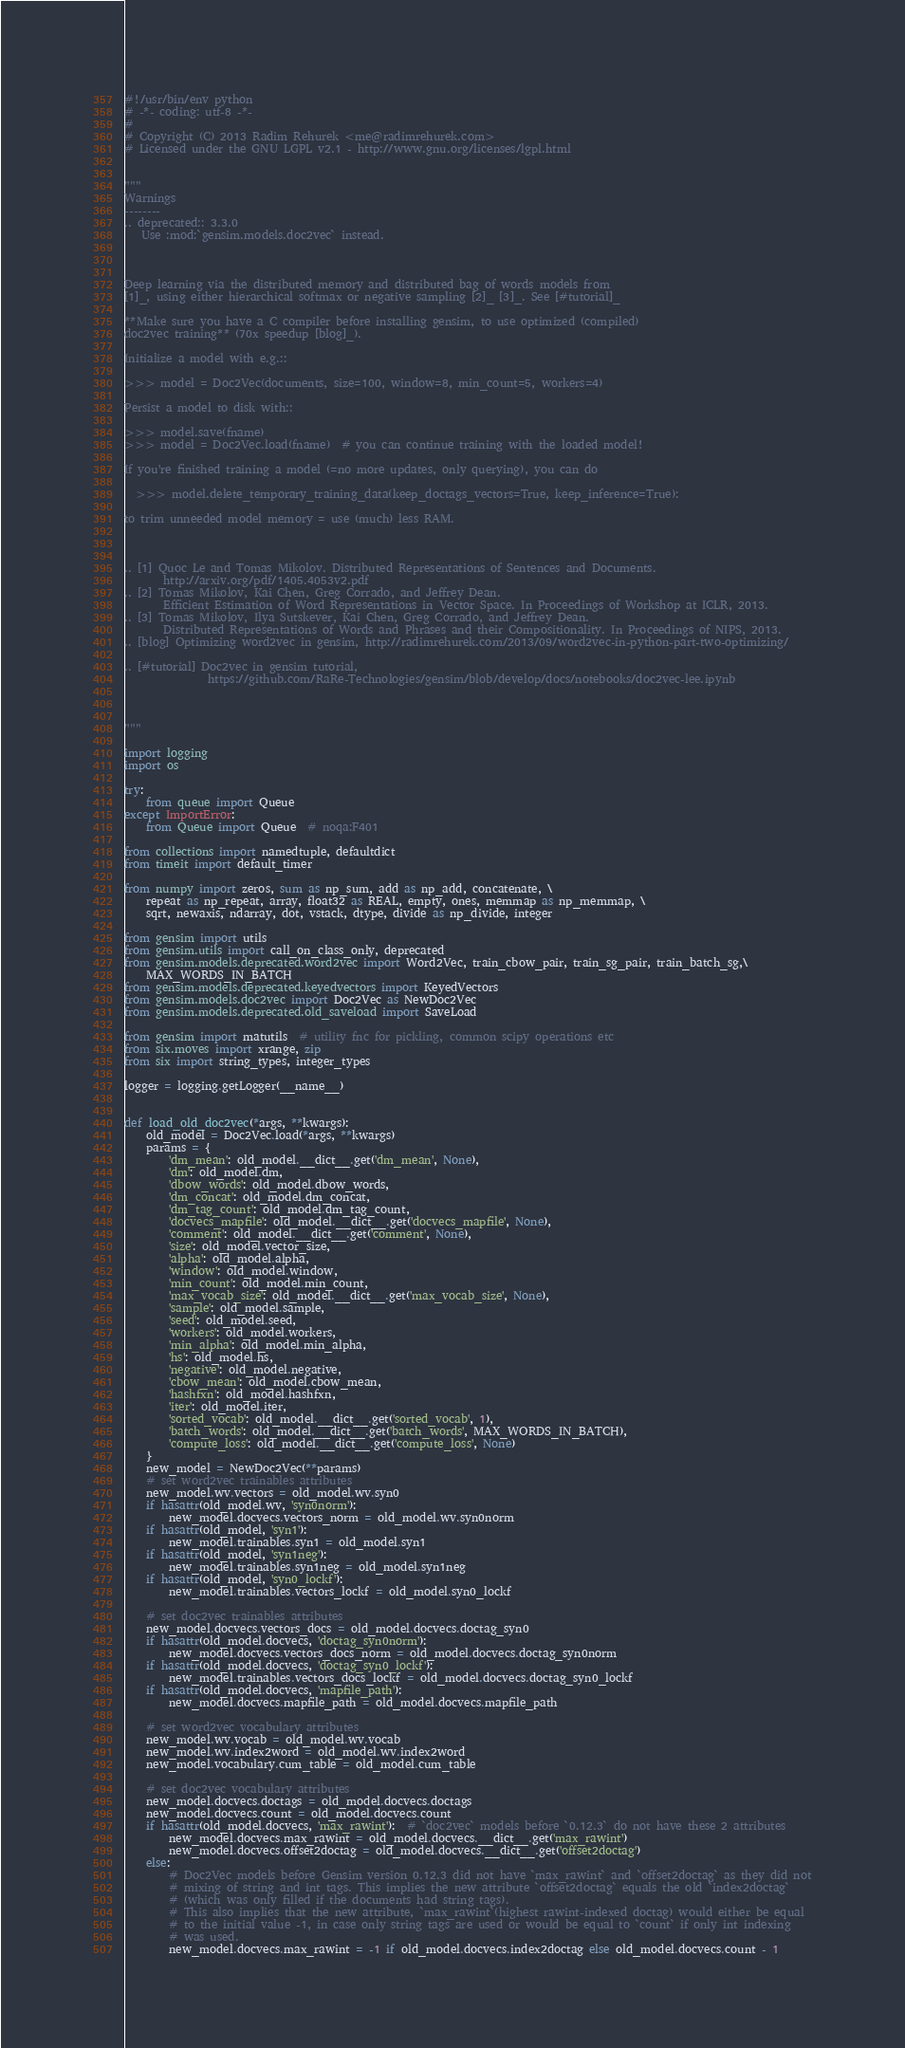Convert code to text. <code><loc_0><loc_0><loc_500><loc_500><_Python_>#!/usr/bin/env python
# -*- coding: utf-8 -*-
#
# Copyright (C) 2013 Radim Rehurek <me@radimrehurek.com>
# Licensed under the GNU LGPL v2.1 - http://www.gnu.org/licenses/lgpl.html


"""
Warnings
--------
.. deprecated:: 3.3.0
   Use :mod:`gensim.models.doc2vec` instead.



Deep learning via the distributed memory and distributed bag of words models from
[1]_, using either hierarchical softmax or negative sampling [2]_ [3]_. See [#tutorial]_

**Make sure you have a C compiler before installing gensim, to use optimized (compiled)
doc2vec training** (70x speedup [blog]_).

Initialize a model with e.g.::

>>> model = Doc2Vec(documents, size=100, window=8, min_count=5, workers=4)

Persist a model to disk with::

>>> model.save(fname)
>>> model = Doc2Vec.load(fname)  # you can continue training with the loaded model!

If you're finished training a model (=no more updates, only querying), you can do

  >>> model.delete_temporary_training_data(keep_doctags_vectors=True, keep_inference=True):

to trim unneeded model memory = use (much) less RAM.



.. [1] Quoc Le and Tomas Mikolov. Distributed Representations of Sentences and Documents.
       http://arxiv.org/pdf/1405.4053v2.pdf
.. [2] Tomas Mikolov, Kai Chen, Greg Corrado, and Jeffrey Dean.
       Efficient Estimation of Word Representations in Vector Space. In Proceedings of Workshop at ICLR, 2013.
.. [3] Tomas Mikolov, Ilya Sutskever, Kai Chen, Greg Corrado, and Jeffrey Dean.
       Distributed Representations of Words and Phrases and their Compositionality. In Proceedings of NIPS, 2013.
.. [blog] Optimizing word2vec in gensim, http://radimrehurek.com/2013/09/word2vec-in-python-part-two-optimizing/

.. [#tutorial] Doc2vec in gensim tutorial,
               https://github.com/RaRe-Technologies/gensim/blob/develop/docs/notebooks/doc2vec-lee.ipynb



"""

import logging
import os

try:
    from queue import Queue
except ImportError:
    from Queue import Queue  # noqa:F401

from collections import namedtuple, defaultdict
from timeit import default_timer

from numpy import zeros, sum as np_sum, add as np_add, concatenate, \
    repeat as np_repeat, array, float32 as REAL, empty, ones, memmap as np_memmap, \
    sqrt, newaxis, ndarray, dot, vstack, dtype, divide as np_divide, integer

from gensim import utils
from gensim.utils import call_on_class_only, deprecated
from gensim.models.deprecated.word2vec import Word2Vec, train_cbow_pair, train_sg_pair, train_batch_sg,\
    MAX_WORDS_IN_BATCH
from gensim.models.deprecated.keyedvectors import KeyedVectors
from gensim.models.doc2vec import Doc2Vec as NewDoc2Vec
from gensim.models.deprecated.old_saveload import SaveLoad

from gensim import matutils  # utility fnc for pickling, common scipy operations etc
from six.moves import xrange, zip
from six import string_types, integer_types

logger = logging.getLogger(__name__)


def load_old_doc2vec(*args, **kwargs):
    old_model = Doc2Vec.load(*args, **kwargs)
    params = {
        'dm_mean': old_model.__dict__.get('dm_mean', None),
        'dm': old_model.dm,
        'dbow_words': old_model.dbow_words,
        'dm_concat': old_model.dm_concat,
        'dm_tag_count': old_model.dm_tag_count,
        'docvecs_mapfile': old_model.__dict__.get('docvecs_mapfile', None),
        'comment': old_model.__dict__.get('comment', None),
        'size': old_model.vector_size,
        'alpha': old_model.alpha,
        'window': old_model.window,
        'min_count': old_model.min_count,
        'max_vocab_size': old_model.__dict__.get('max_vocab_size', None),
        'sample': old_model.sample,
        'seed': old_model.seed,
        'workers': old_model.workers,
        'min_alpha': old_model.min_alpha,
        'hs': old_model.hs,
        'negative': old_model.negative,
        'cbow_mean': old_model.cbow_mean,
        'hashfxn': old_model.hashfxn,
        'iter': old_model.iter,
        'sorted_vocab': old_model.__dict__.get('sorted_vocab', 1),
        'batch_words': old_model.__dict__.get('batch_words', MAX_WORDS_IN_BATCH),
        'compute_loss': old_model.__dict__.get('compute_loss', None)
    }
    new_model = NewDoc2Vec(**params)
    # set word2vec trainables attributes
    new_model.wv.vectors = old_model.wv.syn0
    if hasattr(old_model.wv, 'syn0norm'):
        new_model.docvecs.vectors_norm = old_model.wv.syn0norm
    if hasattr(old_model, 'syn1'):
        new_model.trainables.syn1 = old_model.syn1
    if hasattr(old_model, 'syn1neg'):
        new_model.trainables.syn1neg = old_model.syn1neg
    if hasattr(old_model, 'syn0_lockf'):
        new_model.trainables.vectors_lockf = old_model.syn0_lockf

    # set doc2vec trainables attributes
    new_model.docvecs.vectors_docs = old_model.docvecs.doctag_syn0
    if hasattr(old_model.docvecs, 'doctag_syn0norm'):
        new_model.docvecs.vectors_docs_norm = old_model.docvecs.doctag_syn0norm
    if hasattr(old_model.docvecs, 'doctag_syn0_lockf'):
        new_model.trainables.vectors_docs_lockf = old_model.docvecs.doctag_syn0_lockf
    if hasattr(old_model.docvecs, 'mapfile_path'):
        new_model.docvecs.mapfile_path = old_model.docvecs.mapfile_path

    # set word2vec vocabulary attributes
    new_model.wv.vocab = old_model.wv.vocab
    new_model.wv.index2word = old_model.wv.index2word
    new_model.vocabulary.cum_table = old_model.cum_table

    # set doc2vec vocabulary attributes
    new_model.docvecs.doctags = old_model.docvecs.doctags
    new_model.docvecs.count = old_model.docvecs.count
    if hasattr(old_model.docvecs, 'max_rawint'):  # `doc2vec` models before `0.12.3` do not have these 2 attributes
        new_model.docvecs.max_rawint = old_model.docvecs.__dict__.get('max_rawint')
        new_model.docvecs.offset2doctag = old_model.docvecs.__dict__.get('offset2doctag')
    else:
        # Doc2Vec models before Gensim version 0.12.3 did not have `max_rawint` and `offset2doctag` as they did not
        # mixing of string and int tags. This implies the new attribute `offset2doctag` equals the old `index2doctag`
        # (which was only filled if the documents had string tags).
        # This also implies that the new attribute, `max_rawint`(highest rawint-indexed doctag) would either be equal
        # to the initial value -1, in case only string tags are used or would be equal to `count` if only int indexing
        # was used.
        new_model.docvecs.max_rawint = -1 if old_model.docvecs.index2doctag else old_model.docvecs.count - 1</code> 